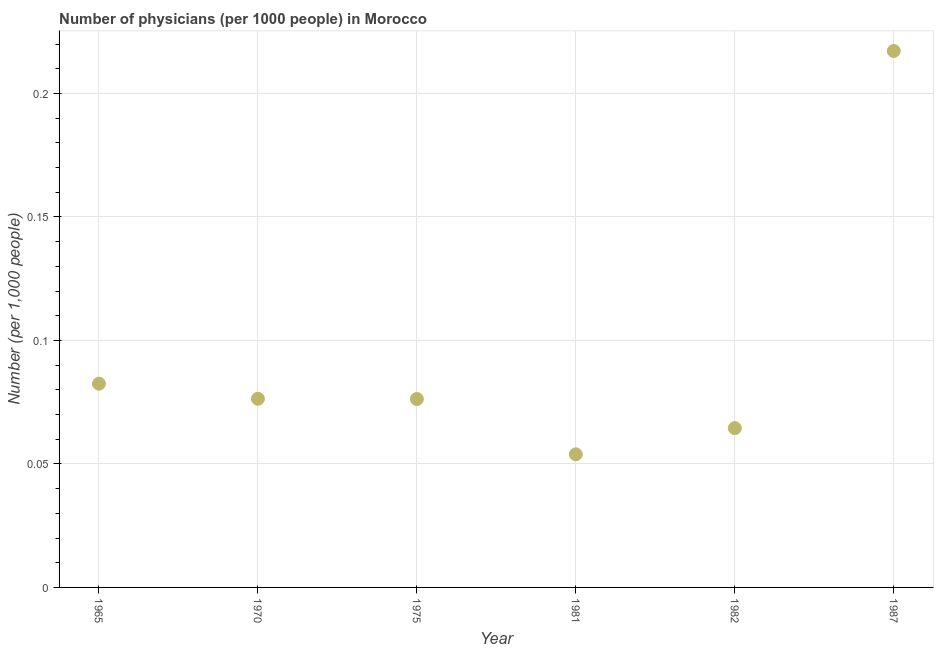What is the number of physicians in 1987?
Give a very brief answer. 0.22. Across all years, what is the maximum number of physicians?
Give a very brief answer. 0.22. Across all years, what is the minimum number of physicians?
Ensure brevity in your answer.  0.05. In which year was the number of physicians minimum?
Keep it short and to the point. 1981. What is the sum of the number of physicians?
Keep it short and to the point. 0.57. What is the difference between the number of physicians in 1965 and 1981?
Your answer should be compact. 0.03. What is the average number of physicians per year?
Give a very brief answer. 0.1. What is the median number of physicians?
Make the answer very short. 0.08. In how many years, is the number of physicians greater than 0.19000000000000003 ?
Your answer should be very brief. 1. What is the ratio of the number of physicians in 1965 to that in 1987?
Provide a succinct answer. 0.38. Is the number of physicians in 1975 less than that in 1981?
Your response must be concise. No. Is the difference between the number of physicians in 1970 and 1981 greater than the difference between any two years?
Your answer should be very brief. No. What is the difference between the highest and the second highest number of physicians?
Provide a short and direct response. 0.13. Is the sum of the number of physicians in 1970 and 1982 greater than the maximum number of physicians across all years?
Your answer should be very brief. No. What is the difference between the highest and the lowest number of physicians?
Offer a terse response. 0.16. In how many years, is the number of physicians greater than the average number of physicians taken over all years?
Your response must be concise. 1. What is the difference between two consecutive major ticks on the Y-axis?
Your answer should be compact. 0.05. Are the values on the major ticks of Y-axis written in scientific E-notation?
Your answer should be compact. No. Does the graph contain any zero values?
Make the answer very short. No. What is the title of the graph?
Keep it short and to the point. Number of physicians (per 1000 people) in Morocco. What is the label or title of the X-axis?
Provide a short and direct response. Year. What is the label or title of the Y-axis?
Your response must be concise. Number (per 1,0 people). What is the Number (per 1,000 people) in 1965?
Give a very brief answer. 0.08. What is the Number (per 1,000 people) in 1970?
Provide a short and direct response. 0.08. What is the Number (per 1,000 people) in 1975?
Ensure brevity in your answer.  0.08. What is the Number (per 1,000 people) in 1981?
Give a very brief answer. 0.05. What is the Number (per 1,000 people) in 1982?
Provide a succinct answer. 0.06. What is the Number (per 1,000 people) in 1987?
Give a very brief answer. 0.22. What is the difference between the Number (per 1,000 people) in 1965 and 1970?
Offer a terse response. 0.01. What is the difference between the Number (per 1,000 people) in 1965 and 1975?
Offer a very short reply. 0.01. What is the difference between the Number (per 1,000 people) in 1965 and 1981?
Offer a terse response. 0.03. What is the difference between the Number (per 1,000 people) in 1965 and 1982?
Make the answer very short. 0.02. What is the difference between the Number (per 1,000 people) in 1965 and 1987?
Offer a terse response. -0.13. What is the difference between the Number (per 1,000 people) in 1970 and 1975?
Your answer should be very brief. 0. What is the difference between the Number (per 1,000 people) in 1970 and 1981?
Your answer should be compact. 0.02. What is the difference between the Number (per 1,000 people) in 1970 and 1982?
Give a very brief answer. 0.01. What is the difference between the Number (per 1,000 people) in 1970 and 1987?
Your response must be concise. -0.14. What is the difference between the Number (per 1,000 people) in 1975 and 1981?
Your answer should be very brief. 0.02. What is the difference between the Number (per 1,000 people) in 1975 and 1982?
Give a very brief answer. 0.01. What is the difference between the Number (per 1,000 people) in 1975 and 1987?
Give a very brief answer. -0.14. What is the difference between the Number (per 1,000 people) in 1981 and 1982?
Offer a very short reply. -0.01. What is the difference between the Number (per 1,000 people) in 1981 and 1987?
Provide a short and direct response. -0.16. What is the difference between the Number (per 1,000 people) in 1982 and 1987?
Give a very brief answer. -0.15. What is the ratio of the Number (per 1,000 people) in 1965 to that in 1970?
Provide a short and direct response. 1.08. What is the ratio of the Number (per 1,000 people) in 1965 to that in 1975?
Keep it short and to the point. 1.08. What is the ratio of the Number (per 1,000 people) in 1965 to that in 1981?
Make the answer very short. 1.53. What is the ratio of the Number (per 1,000 people) in 1965 to that in 1982?
Offer a terse response. 1.28. What is the ratio of the Number (per 1,000 people) in 1965 to that in 1987?
Ensure brevity in your answer.  0.38. What is the ratio of the Number (per 1,000 people) in 1970 to that in 1975?
Your answer should be very brief. 1. What is the ratio of the Number (per 1,000 people) in 1970 to that in 1981?
Your response must be concise. 1.42. What is the ratio of the Number (per 1,000 people) in 1970 to that in 1982?
Your answer should be very brief. 1.18. What is the ratio of the Number (per 1,000 people) in 1970 to that in 1987?
Provide a succinct answer. 0.35. What is the ratio of the Number (per 1,000 people) in 1975 to that in 1981?
Keep it short and to the point. 1.42. What is the ratio of the Number (per 1,000 people) in 1975 to that in 1982?
Offer a terse response. 1.18. What is the ratio of the Number (per 1,000 people) in 1975 to that in 1987?
Your response must be concise. 0.35. What is the ratio of the Number (per 1,000 people) in 1981 to that in 1982?
Keep it short and to the point. 0.84. What is the ratio of the Number (per 1,000 people) in 1981 to that in 1987?
Offer a terse response. 0.25. What is the ratio of the Number (per 1,000 people) in 1982 to that in 1987?
Your answer should be very brief. 0.3. 